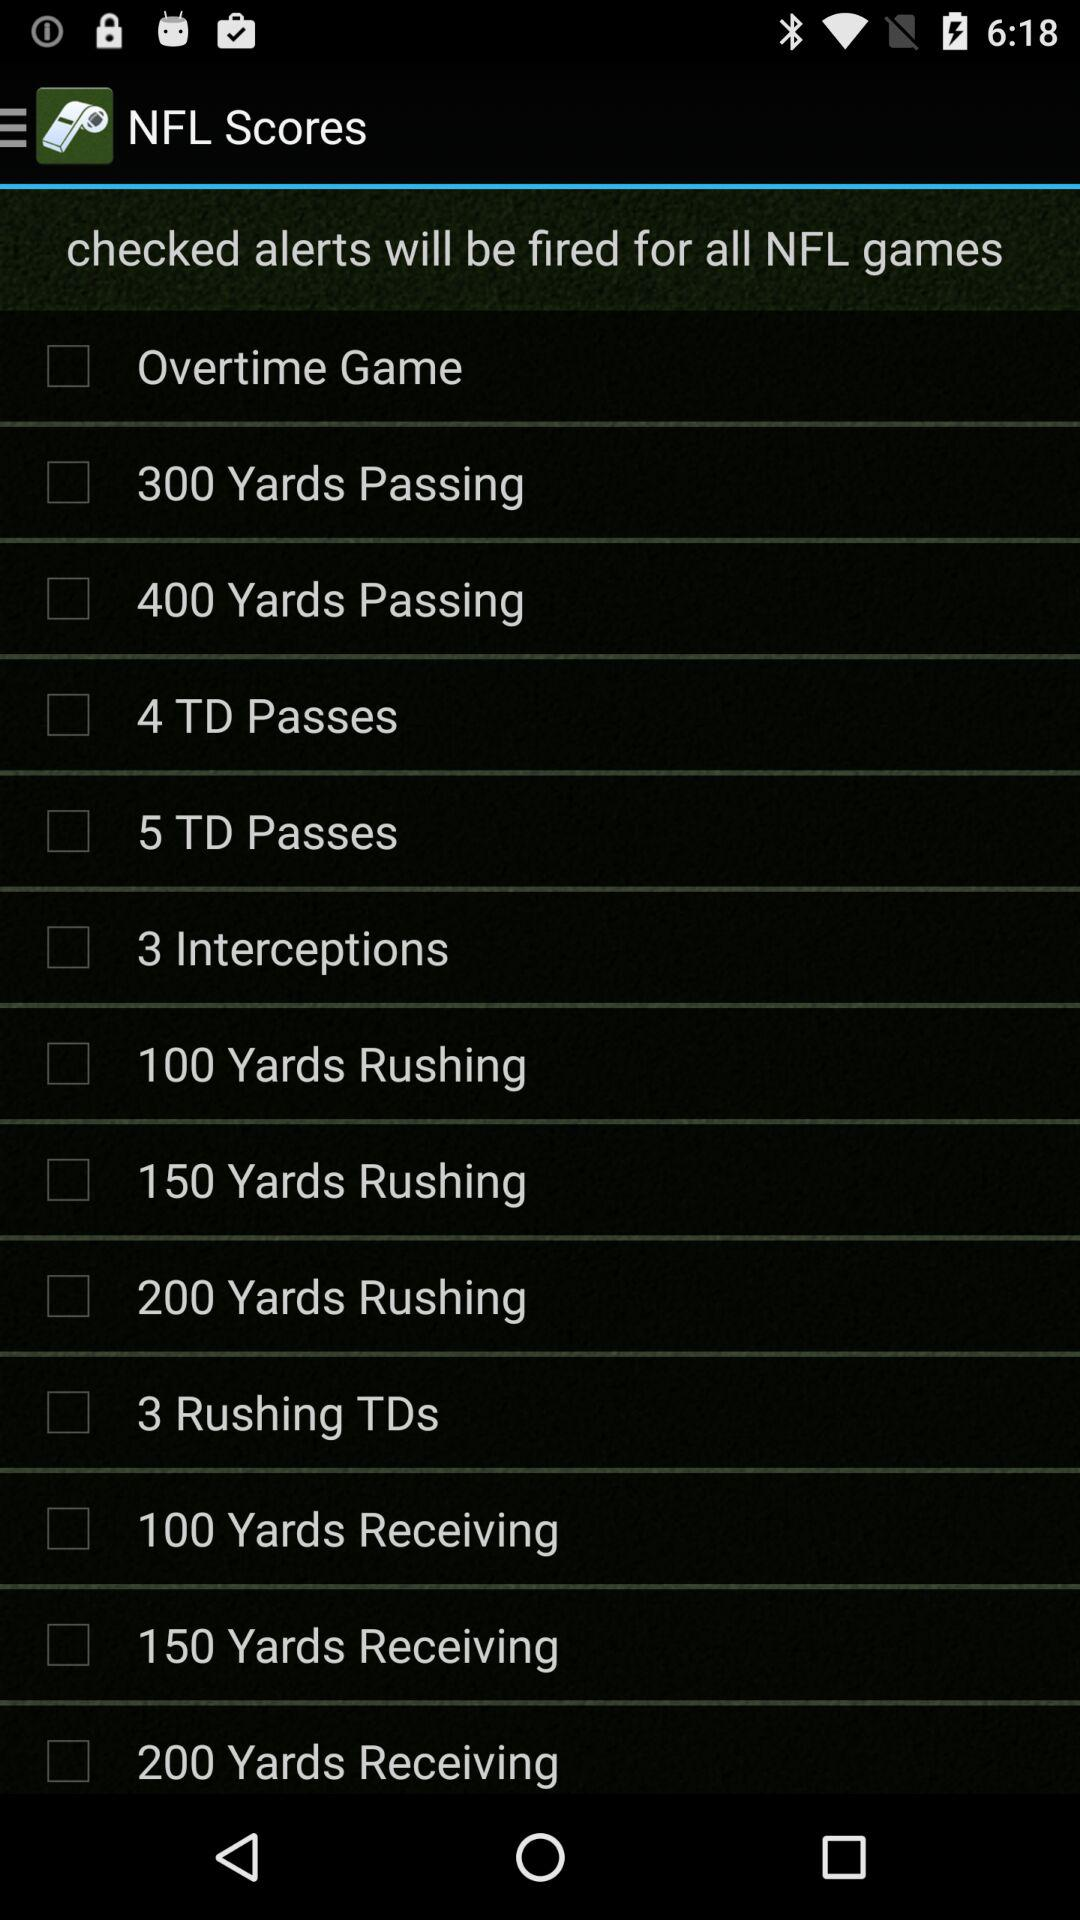What is the status of the "Overtime Game"? The status is "off". 